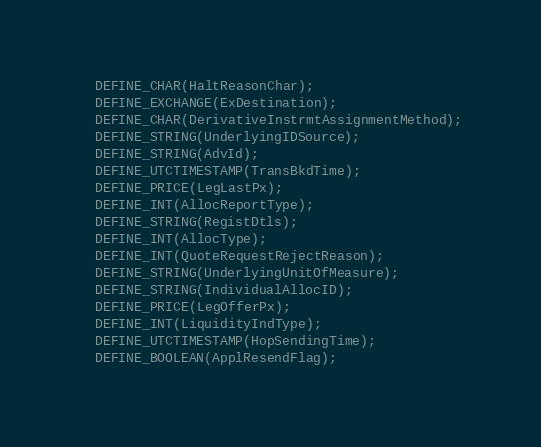<code> <loc_0><loc_0><loc_500><loc_500><_C_>  DEFINE_CHAR(HaltReasonChar);
  DEFINE_EXCHANGE(ExDestination);
  DEFINE_CHAR(DerivativeInstrmtAssignmentMethod);
  DEFINE_STRING(UnderlyingIDSource);
  DEFINE_STRING(AdvId);
  DEFINE_UTCTIMESTAMP(TransBkdTime);
  DEFINE_PRICE(LegLastPx);
  DEFINE_INT(AllocReportType);
  DEFINE_STRING(RegistDtls);
  DEFINE_INT(AllocType);
  DEFINE_INT(QuoteRequestRejectReason);
  DEFINE_STRING(UnderlyingUnitOfMeasure);
  DEFINE_STRING(IndividualAllocID);
  DEFINE_PRICE(LegOfferPx);
  DEFINE_INT(LiquidityIndType);
  DEFINE_UTCTIMESTAMP(HopSendingTime);
  DEFINE_BOOLEAN(ApplResendFlag);</code> 